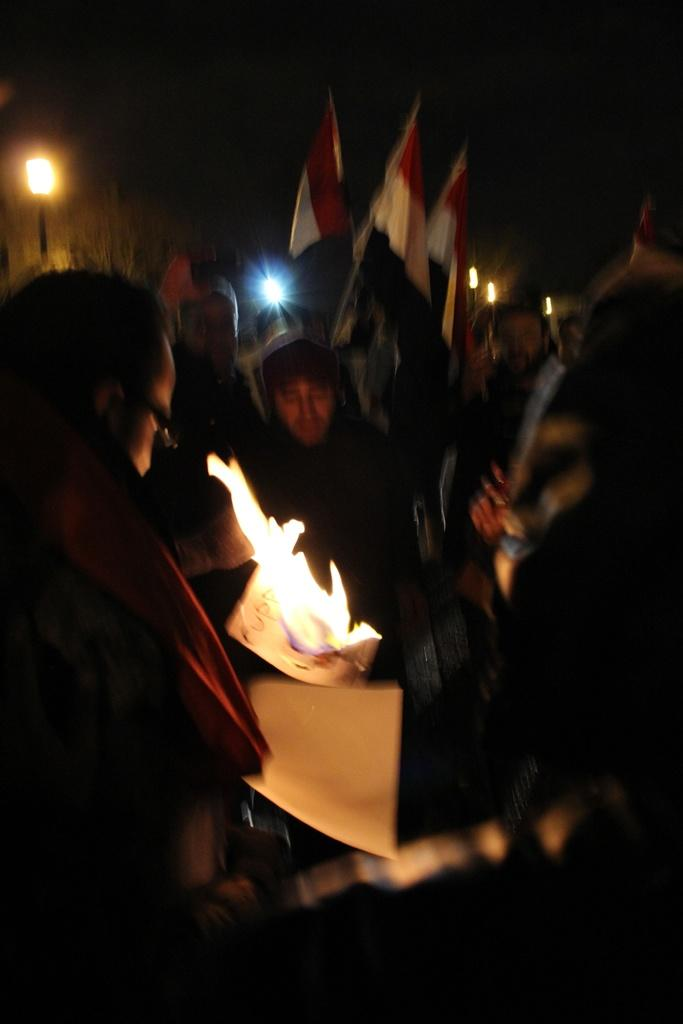How many people are in the image? There are persons in the image, but the exact number is not specified. What else can be seen in the image besides the persons? There are flags and lights in the image. What is the central feature of the image? There is a fire in the center of the image. What type of current can be seen flowing through the hill in the image? There is no hill or current present in the image. What shape is the square in the image? There is no square present in the image. 